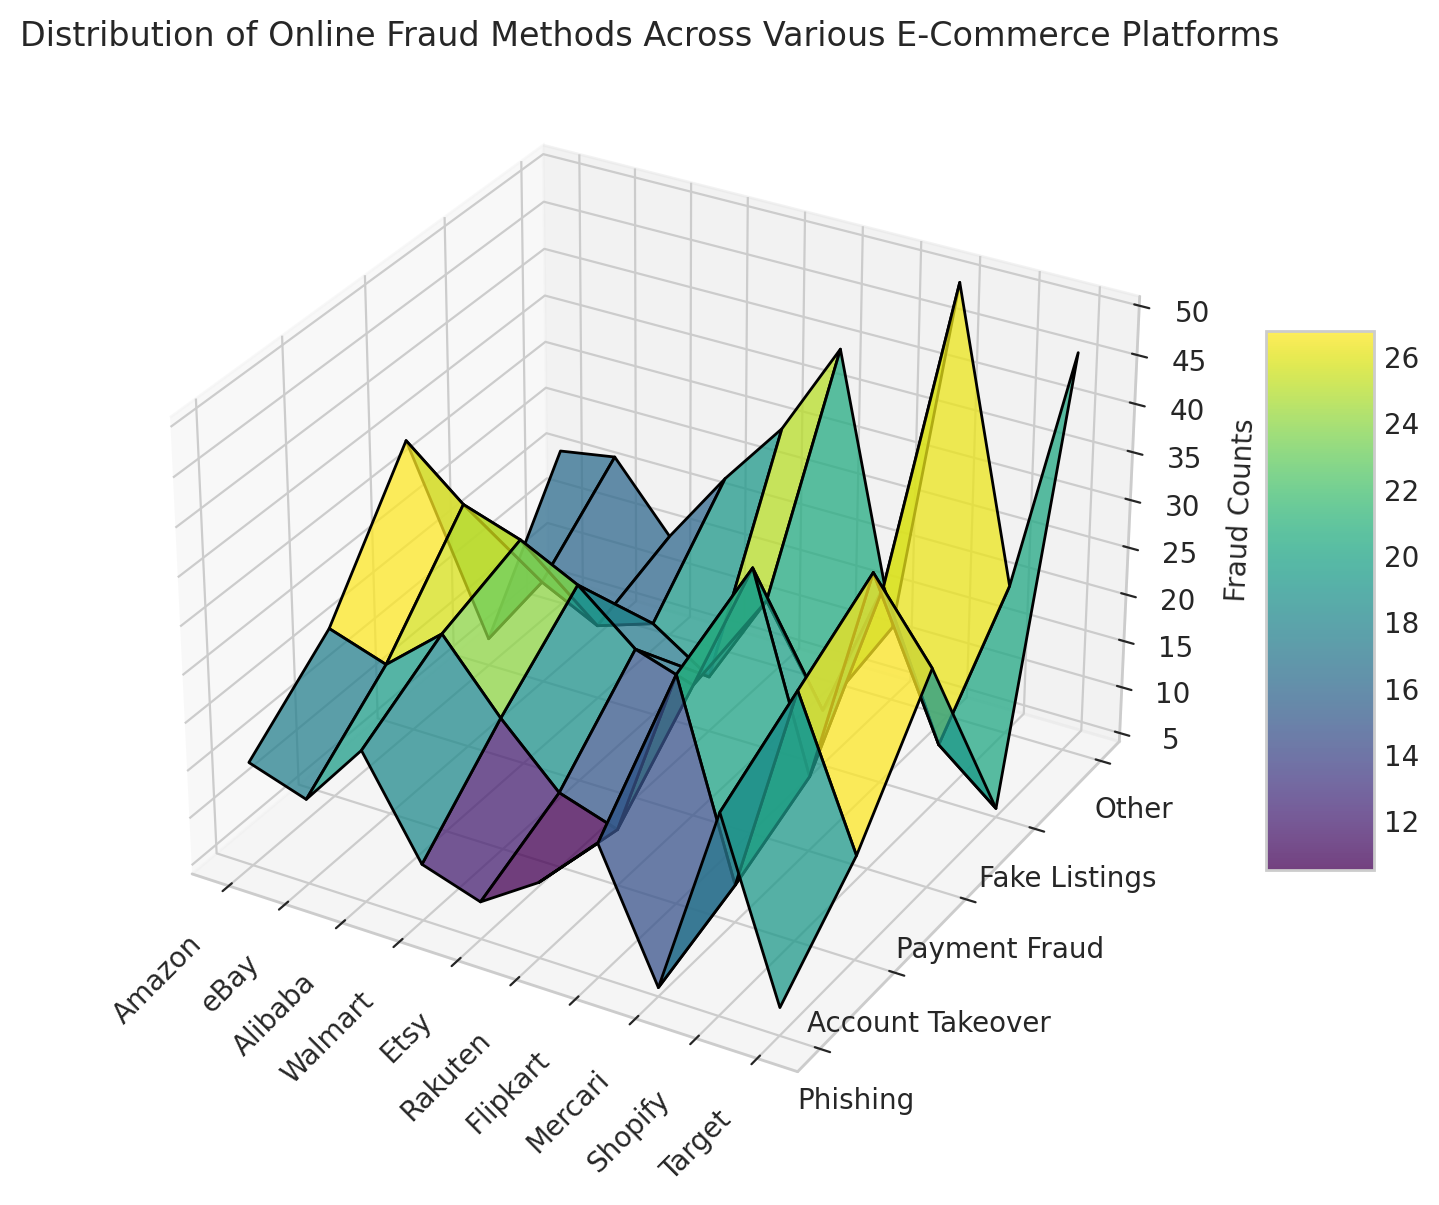What platform reports the highest count of 'Other' fraud methods? The figure shows the counts of different fraud methods across platforms. By looking at the vertical height of the 'Other' category, we can see which one is the highest. Mercari has the highest count in the 'Other' fraud methods.
Answer: Mercari Which platform has the lowest 'Phishing' fraud count? Compare the vertical heights of the 'Phishing' category across all platforms. Mercari has the lowest height in this category.
Answer: Mercari Between Amazon and eBay, which has a higher total count of fraud methods? Add the fraud counts for both platforms across all categories. For Amazon: 15 + 22 + 35 + 7 + 21 = 100. For eBay: 13 + 20 + 30 + 15 + 22 = 100. They have the same total count.
Answer: Same What is the average count of 'Payment Fraud' across all platforms? Sum the 'Payment Fraud' counts for each platform and divide by the number of platforms: (35 + 30 + 28 + 25 + 20 + 18 + 32 + 12 + 35 + 27) / 10 = 26.2
Answer: 26.2 Which fraud method has the highest count on Shopify? Look at the vertical heights of each fraud method for Shopify. 'Payment Fraud' has the highest height.
Answer: Payment Fraud Which method on Walmart has the closest count to 'Fake Listings' method on Etsy? The 'Fake Listings' count on Etsy is 10. On Walmart, 'Other' has a count of 23, closest to this value.
Answer: Other Is the count of 'Account Takeover' fraud higher on Flipkart or Alibaba? Compare the vertical heights of the 'Account Takeover' category between Flipkart and Alibaba. Flipkart has a higher count in 'Account Takeover'.
Answer: Flipkart What is the sum of 'Phishing' and 'Fake Listings' on Rakuten? Add the 'Phishing' and 'Fake Listings' counts for Rakuten: 12 + 20 = 32.
Answer: 32 Which platform shows a greater variance across all fraud methods, Etsy or Target? Calculate the variance of fraud counts for both platforms and compare. For Etsy: variance(8, 12, 20, 10, 30) = 92.4. For Target: variance(7, 15, 27, 5, 46) = 235. Both manually handled. Target shows greater variance.
Answer: Target 